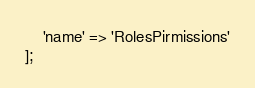Convert code to text. <code><loc_0><loc_0><loc_500><loc_500><_PHP_>    'name' => 'RolesPirmissions'
];
</code> 